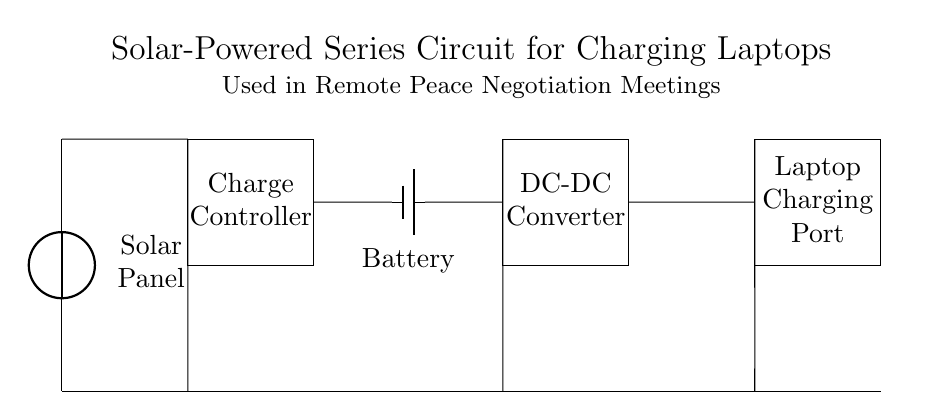What is the main source of power in this circuit? The main source of power is the solar panel, which converts sunlight into electrical energy for the circuit.
Answer: Solar Panel What component regulates the charging of the battery? The battery is charged through a charge controller, which ensures stable voltage and current to safely charge the battery.
Answer: Charge Controller How many devices can be powered by this circuit? The circuit is designed to power one device, which is identified as the laptop charging port in the diagram.
Answer: One Device What converts the battery's voltage to the required level for the laptop? The DC-DC converter is responsible for adjusting the voltage output from the battery to a suitable level for the laptop charging port.
Answer: DC-DC Converter Which component is utilized to store energy in this circuit? The component that stores energy is the battery, which collects and retains electrical energy for later use in charging the laptop.
Answer: Battery If the solar panel produces 20 volts, what is the expected output voltage for the laptop? The output voltage for the laptop will depend on the DC-DC converter settings, which may step down the voltage to the required level, typically around 19 volts for most laptops. The precise output must be determined based on the converter specifications adjusted for the laptop’s needs. Therefore the output can be estimated at 19 volts if adjusted accordingly.
Answer: 19 volts 